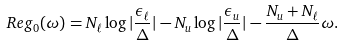Convert formula to latex. <formula><loc_0><loc_0><loc_500><loc_500>R e g _ { 0 } ( \omega ) = N _ { \ell } \log | \frac { \epsilon _ { \ell } } { \Delta } | - N _ { u } \log | \frac { \epsilon _ { u } } { \Delta } | - \frac { N _ { u } + N _ { \ell } } { \Delta } \omega .</formula> 